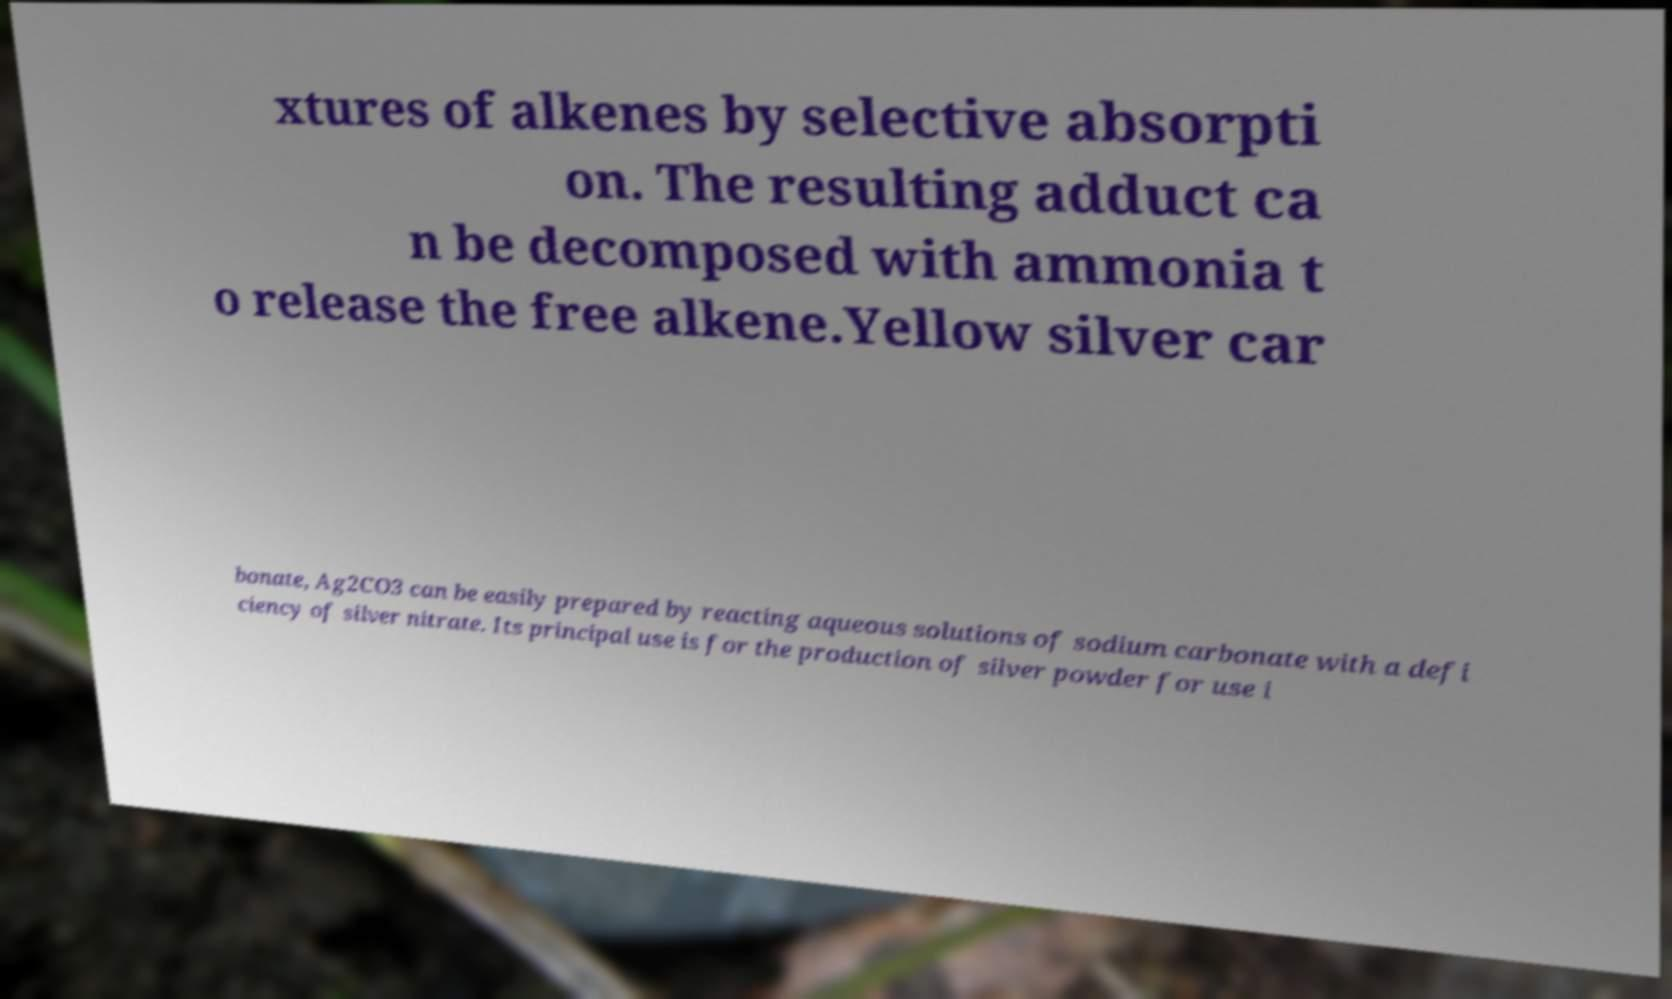There's text embedded in this image that I need extracted. Can you transcribe it verbatim? xtures of alkenes by selective absorpti on. The resulting adduct ca n be decomposed with ammonia t o release the free alkene.Yellow silver car bonate, Ag2CO3 can be easily prepared by reacting aqueous solutions of sodium carbonate with a defi ciency of silver nitrate. Its principal use is for the production of silver powder for use i 